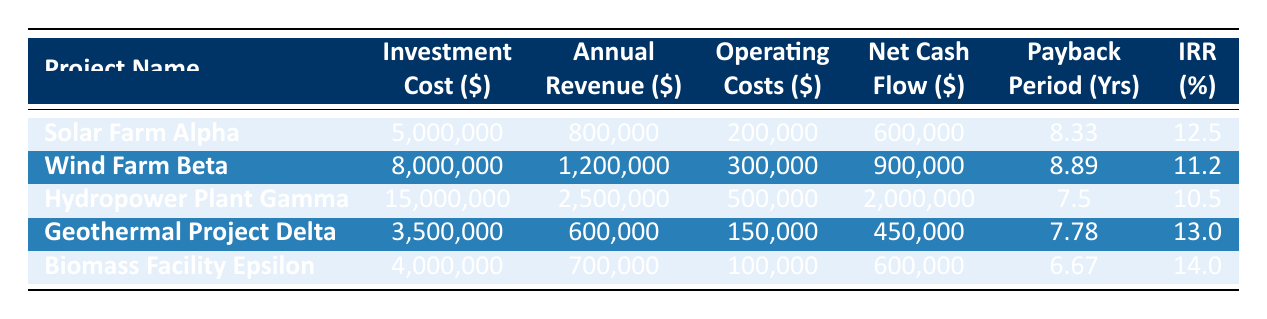What is the investment cost of the Geothermal Project Delta? The investment cost is listed under the "Investment Cost ($)" column for Geothermal Project Delta. It states $3,500,000.
Answer: 3,500,000 Which project has the highest net cash flow? By comparing the "Net Cash Flow ($)" column, Hydropower Plant Gamma shows the highest value at $2,000,000.
Answer: Hydropower Plant Gamma What is the payback period for Biomass Facility Epsilon? Looking at the "Payback Period (Yrs)" column, Biomass Facility Epsilon has a payback period of 6.67 years.
Answer: 6.67 What’s the average annual revenue among all projects? The annual revenues are $800,000, $1,200,000, $2,500,000, $600,000, and $700,000. Adding these gives 5,800,000. Dividing by 5 projects gives 5,800,000 / 5 = 1,160,000.
Answer: 1,160,000 Is the internal rate of return for Wind Farm Beta greater than 12%? Wind Farm Beta has an internal rate of return of 11.2%, which is less than 12%.
Answer: No What is the difference in investment cost between the Hydropower Plant Gamma and Biomass Facility Epsilon? The investment cost for Hydropower Plant Gamma is $15,000,000, and for Biomass Facility Epsilon, it is $4,000,000. The difference is 15,000,000 - 4,000,000 = 11,000,000.
Answer: 11,000,000 Which project has the longest project lifetime? By looking at the "Project Lifetime (Years)" column, Hydropower Plant Gamma has the longest project lifetime of 30 years.
Answer: Hydropower Plant Gamma If we combine the net cash flows of Solar Farm Alpha and Geothermal Project Delta, what is the total? The net cash flows are $600,000 for Solar Farm Alpha and $450,000 for Geothermal Project Delta. Adding these gives 600,000 + 450,000 = 1,050,000.
Answer: 1,050,000 What percentage of the investment cost does the annual revenue represent for Wind Farm Beta? The annual revenue for Wind Farm Beta is $1,200,000, and the investment cost is $8,000,000. The percentage is (1,200,000 / 8,000,000) * 100 = 15%.
Answer: 15% Which project has the lowest operating costs and what is that amount? The operating costs are listed as $200,000 for Solar Farm Alpha, $300,000 for Wind Farm Beta, $500,000 for Hydropower Plant Gamma, $150,000 for Geothermal Project Delta, and $100,000 for Biomass Facility Epsilon. The lowest is $100,000 for Biomass Facility Epsilon.
Answer: Biomass Facility Epsilon, $100,000 Which project has the highest internal rate of return? The internal rates of return are 12.5% for Solar Farm Alpha, 11.2% for Wind Farm Beta, 10.5% for Hydropower Plant Gamma, 13.0% for Geothermal Project Delta, and 14.0% for Biomass Facility Epsilon. The highest is 14.0% for Biomass Facility Epsilon.
Answer: Biomass Facility Epsilon, 14.0% 